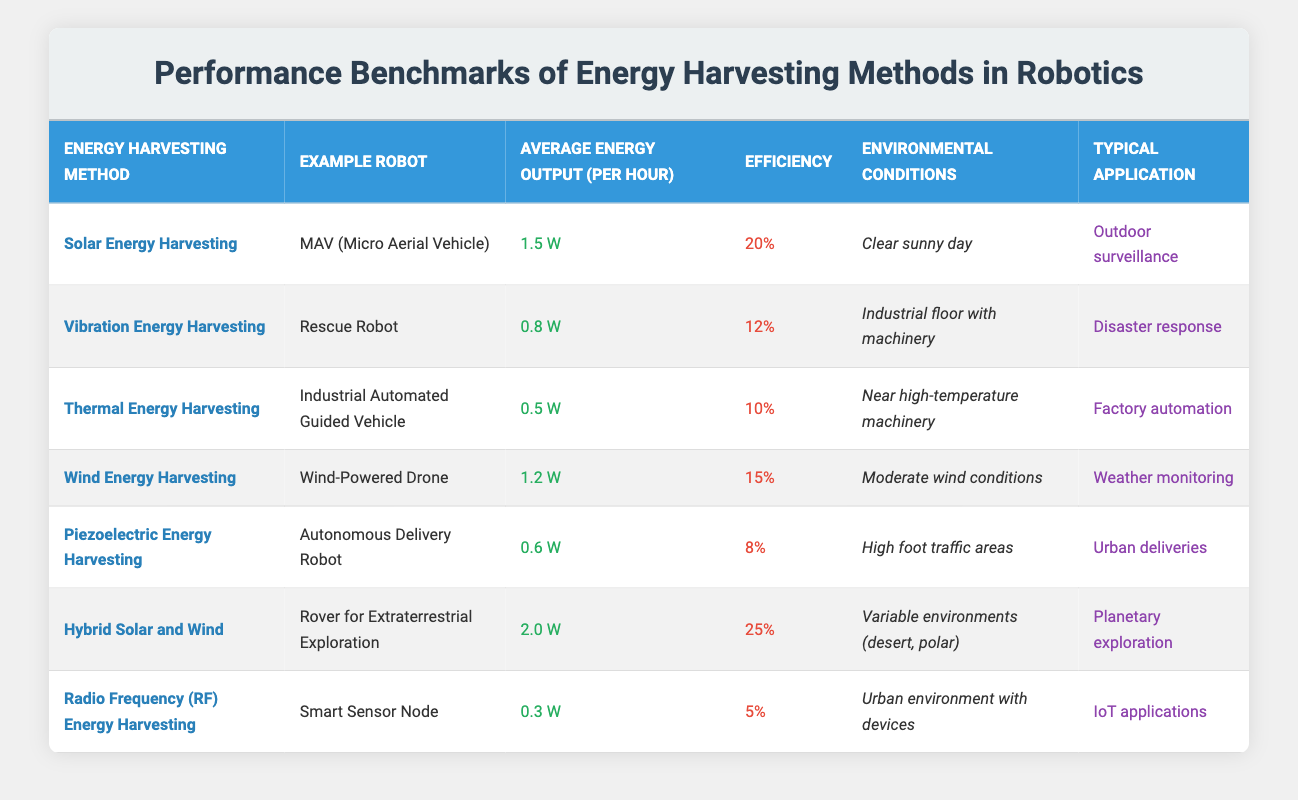What is the average energy output of the "Hybrid Solar and Wind" method? The table indicates an average energy output of 2.0 W for the "Hybrid Solar and Wind" method.
Answer: 2.0 W Which energy harvesting method has the highest efficiency? The "Hybrid Solar and Wind" method has the highest efficiency of 25%, as noted in the efficiency column of the table.
Answer: Hybrid Solar and Wind Is the average energy output of the "Piezoelectric Energy Harvesting" method greater than 0.5 W? The "Piezoelectric Energy Harvesting" method has an average energy output of 0.6 W, which is greater than 0.5 W.
Answer: Yes How does the efficiency of "Thermal Energy Harvesting" compare to that of "Vibration Energy Harvesting"? "Thermal Energy Harvesting" has an efficiency of 10%, while "Vibration Energy Harvesting" has an efficiency of 12%. Therefore, "Vibration Energy Harvesting" is more efficient.
Answer: Vibration Energy Harvesting is more efficient What is the sum of the average energy outputs of all methods listed? The average energy outputs are 1.5 W (Solar) + 0.8 W (Vibration) + 0.5 W (Thermal) + 1.2 W (Wind) + 0.6 W (Piezoelectric) + 2.0 W (Hybrid) + 0.3 W (RF) = 7.9 W.
Answer: 7.9 W Which robot uses "Radio Frequency (RF) Energy Harvesting"? The table shows that the "Smart Sensor Node" uses "Radio Frequency (RF) Energy Harvesting".
Answer: Smart Sensor Node What is the typical application of the "Autonomous Delivery Robot"? According to the table, the typical application of the "Autonomous Delivery Robot" is for urban deliveries.
Answer: Urban deliveries How many methods listed have an efficiency of 10% or lower? The methods with 10% or lower efficiency include Thermal (10%), Piezoelectric (8%), and RF (5%). Therefore, there are three methods in total.
Answer: 3 methods What average energy output can you expect from a "Wind-Powered Drone"? The average energy output of the "Wind-Powered Drone" is stated to be 1.2 W according to the table.
Answer: 1.2 W Which method's typical application is "Disaster response"? The "Vibration Energy Harvesting" method's typical application is "Disaster response", as revealed in the table.
Answer: Vibration Energy Harvesting What is the average energy output of robots using energy harvesting methods in moderate conditions? The methods applicable in moderate conditions are Wind Energy Harvesting (1.2 W) and Hybrid (2.0 W). The average is (1.2 W + 2.0 W) / 2 = 1.6 W.
Answer: 1.6 W 